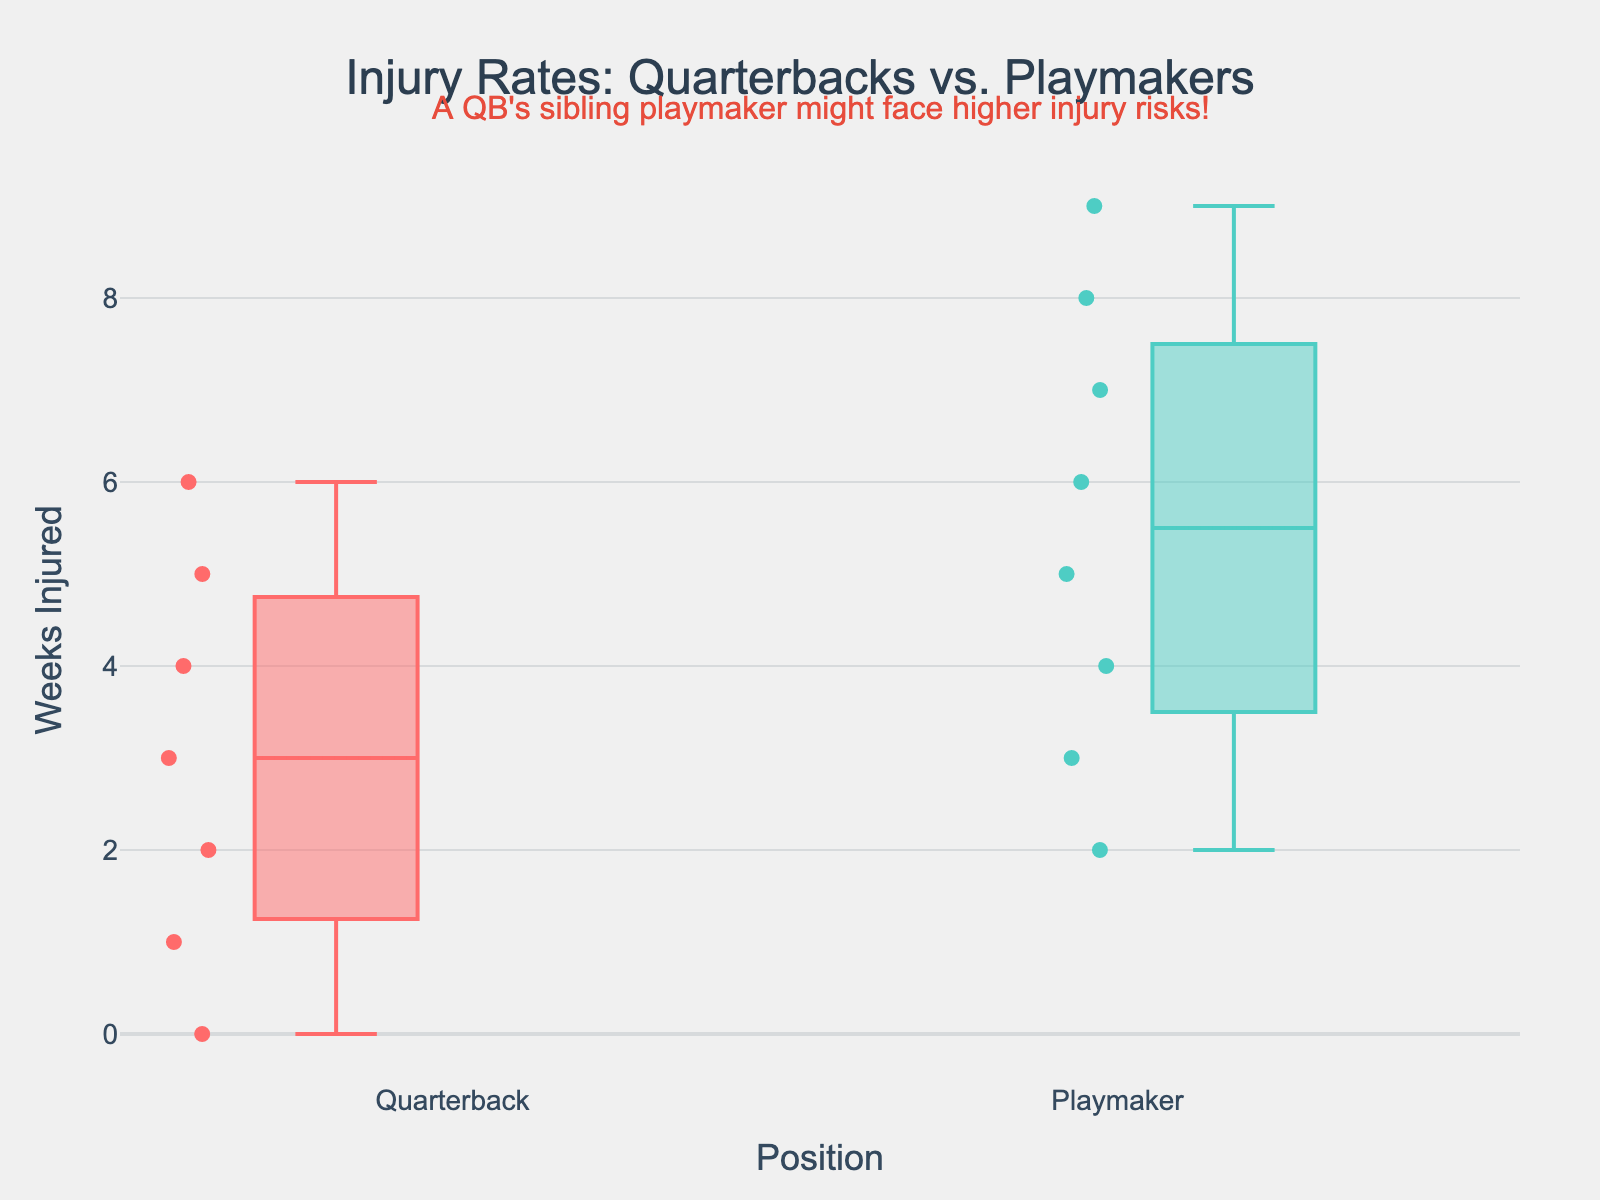What is the title of the plot? The title of the plot is displayed at the top of the figure. It represents the main topic or question the plot addresses.
Answer: Injury Rates: Quarterbacks vs. Playmakers What are the positions compared in this box plot? The positions compared are listed on the x-axis. Each box corresponds to a distinct position.
Answer: Quarterback, Playmaker Which position shows a higher median number of weeks injured? Look at the line in the middle of each box, which represents the median. Compare the position of these lines for both boxes.
Answer: Playmaker What is the range of injury weeks for quarterbacks? The range of injury weeks is determined by the difference between the maximum and minimum values. The whiskers of the box for quarterbacks indicate the range.
Answer: 0 to 6 weeks Which quarterback had the maximum number of injury weeks, and how many weeks were they injured? Refer to the individual data points plotted along the box for quarterbacks. The highest point indicates the quarterback with the maximum injury weeks.
Answer: Dak Prescott, 6 weeks What is the mean number of injury weeks for playmakers, as indicated in the plot? The mean is often indicated by a symbol (e.g., a diamond) within the box. Interpret this symbol's position relative to the y-axis.
Answer: Approximately 5.5 weeks How many quarterbacks were evaluated in this plot? Each data point within the quarterbacks' box represents a player. Count these points to determine the number.
Answer: 7 Comparatively, which group shows more variability in injury weeks? Variability is shown by the spread of the data points and the length of the box and whiskers. Compare these aspects for both groups.
Answer: Playmakers What statistical measure is represented by the horizontal line within each box? The horizontal line inside each box plot indicates a particular central tendency measure.
Answer: Median What is the custom annotation added to the plot, and where is it located? The custom annotation provides additional contextual information and is located relative to a certain part of the plot.
Answer: "A QB's sibling playmaker might face higher injury risks!", located above the plot 